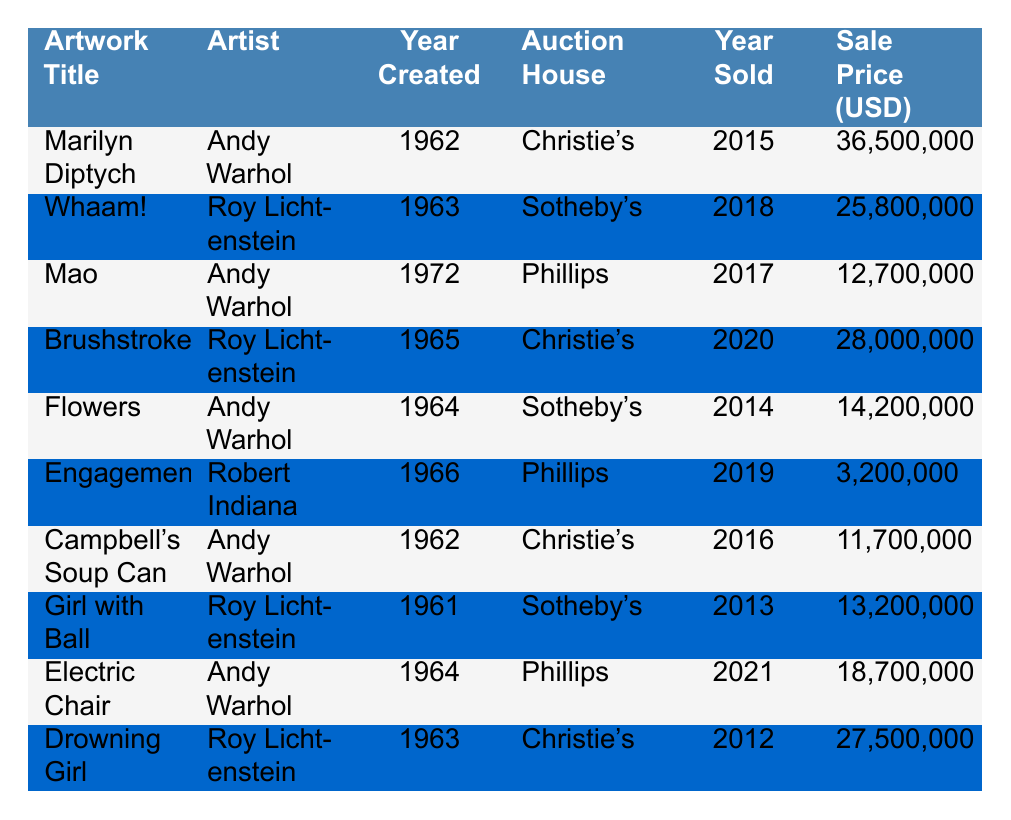What is the highest sale price listed in the table? The table shows various sale prices for artworks. The highest price is 36,500,000 for "Marilyn Diptych."
Answer: 36,500,000 Which artist sold the artwork "Whaam!"? The table lists "Whaam!" under the artist Roy Lichtenstein.
Answer: Roy Lichtenstein How many artworks were sold in 2014? The table lists one artwork, "Flowers," sold in 2014.
Answer: 1 What was the total sale price of Andy Warhol's works listed in the table? From the table, Warhol's works include "Marilyn Diptych" (36,500,000), "Mao" (12,700,000), "Flowers" (14,200,000), "Campbell's Soup Can" (11,700,000), and "Electric Chair" (18,700,000). Adding these gives 36,500,000 + 12,700,000 + 14,200,000 + 11,700,000 + 18,700,000 = 93,800,000.
Answer: 93,800,000 Was "Brushstroke" sold at Sotheby’s? "Brushstroke" is listed under Christie's in the table, not Sotheby's.
Answer: No Which artwork had the second highest sale price? After identifying the highest price (36,500,000 for "Marilyn Diptych"), the second highest is "Whaam!" with a sale price of 25,800,000.
Answer: 25,800,000 What is the average sale price of artworks sold in the year 2016? The table lists two artworks sold in 2016: "Campbell's Soup Can" (11,700,000) and "Marilyn Diptych" (36,500,000). The average is (11,700,000 + 36,500,000) / 2 = 24,100,000.
Answer: 24,100,000 How many screen printed artworks were sold by Roy Lichtenstein? The table lists three artworks by Roy Lichtenstein: "Whaam!", "Brushstroke", and "Drowning Girl."
Answer: 3 Did any artwork created in 1966 sell for more than 10 million USD? The only artwork from 1966, "Engagement," sold for 3,200,000, which is less than 10 million USD.
Answer: No What is the difference in sale price between "Electric Chair" and "Mao"? The sale price for "Electric Chair" (18,700,000) minus "Mao" (12,700,000) equals 18,700,000 - 12,700,000 = 6,000,000.
Answer: 6,000,000 Which auction house sold the most expensive artwork? The most expensive artwork "Marilyn Diptych" was sold at Christie's, making it the auction house for the highest sale price listed.
Answer: Christie's 